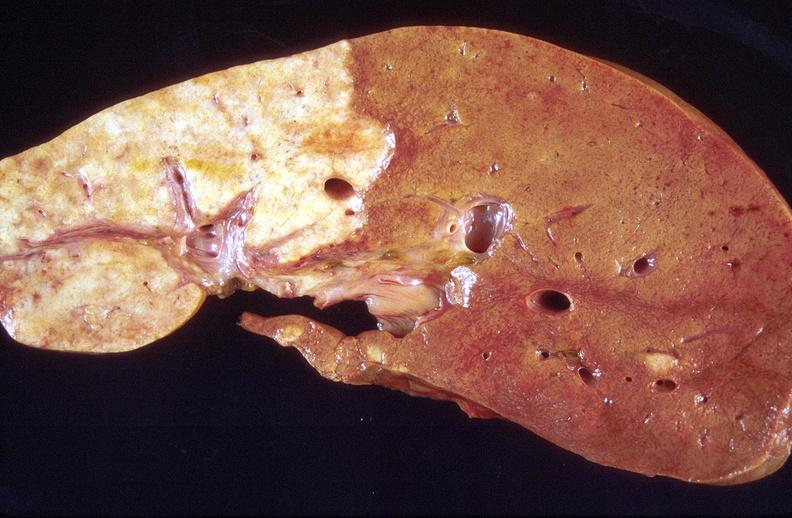does metastatic colon cancer show cholangiocarcinoma?
Answer the question using a single word or phrase. No 